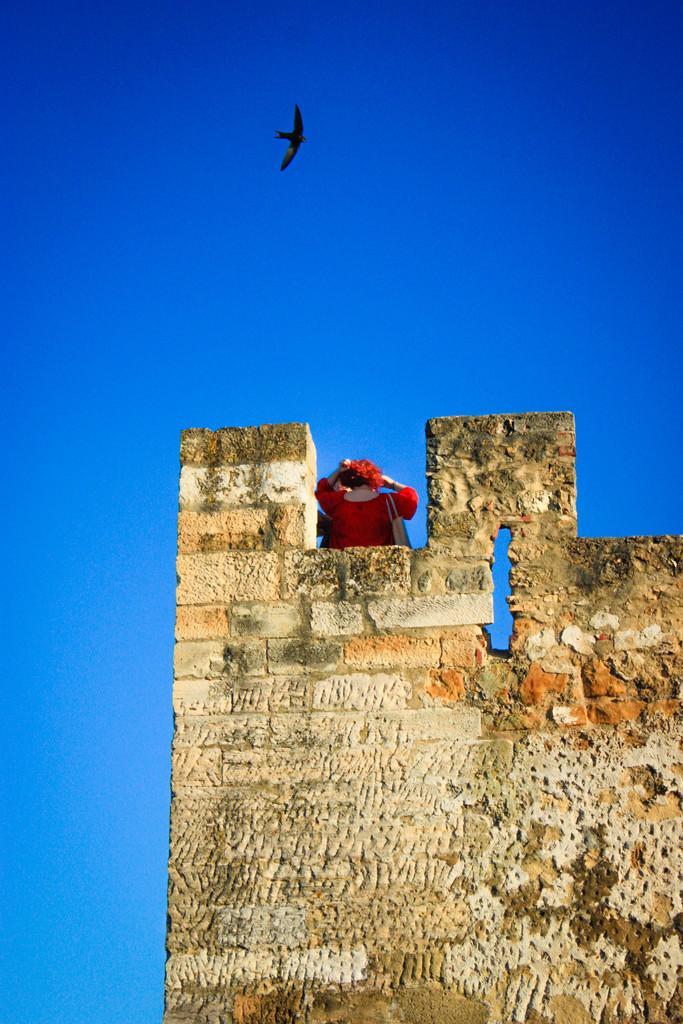Could you give a brief overview of what you see in this image? In this image we can see a girl standing at the top of a building. At the top of the image there is an eagle flying in the sky. 